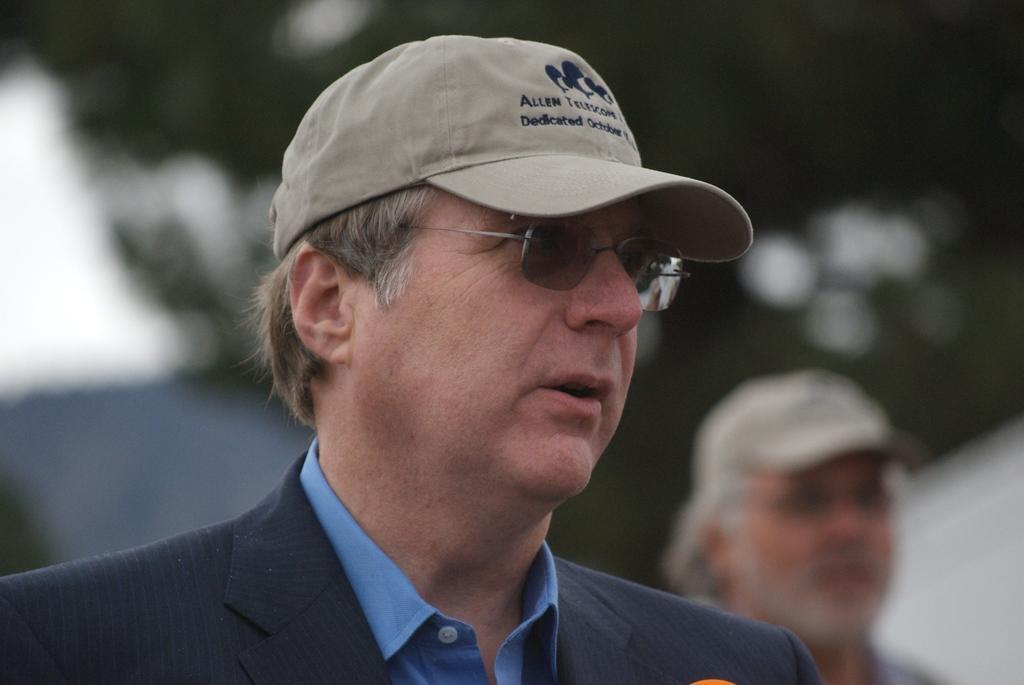Can you describe this image briefly? In this image we can see a person who is wearing a black suite with a blue shirt and he is also wearing a cap he also has spectacles, his mouth is open which means he is speaking and at the back there is another person and he is also wearing a cap and the background is almost blurred. 